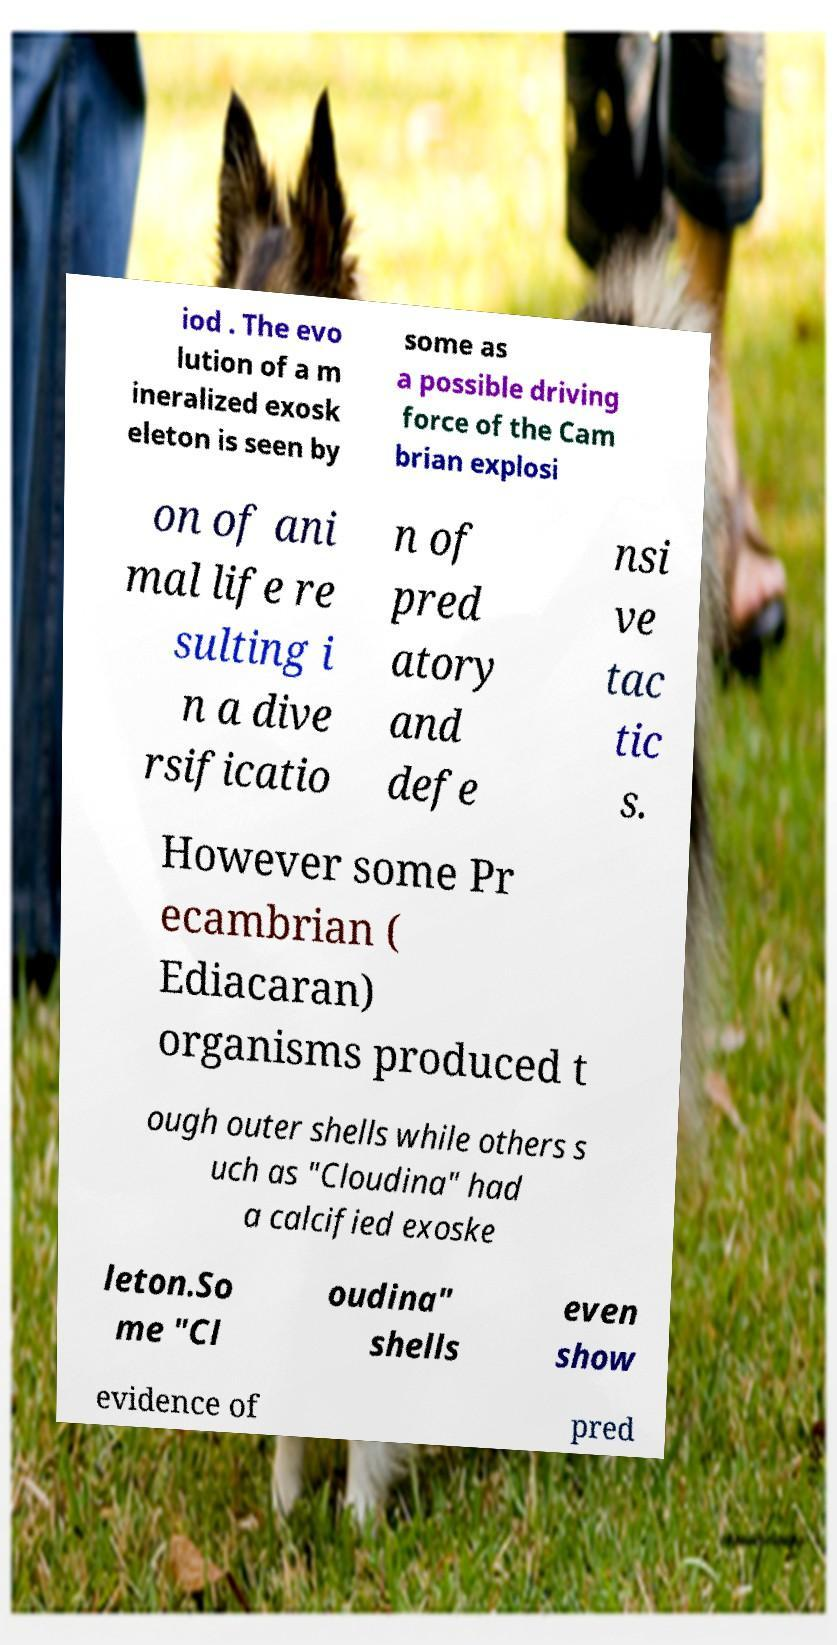There's text embedded in this image that I need extracted. Can you transcribe it verbatim? iod . The evo lution of a m ineralized exosk eleton is seen by some as a possible driving force of the Cam brian explosi on of ani mal life re sulting i n a dive rsificatio n of pred atory and defe nsi ve tac tic s. However some Pr ecambrian ( Ediacaran) organisms produced t ough outer shells while others s uch as "Cloudina" had a calcified exoske leton.So me "Cl oudina" shells even show evidence of pred 